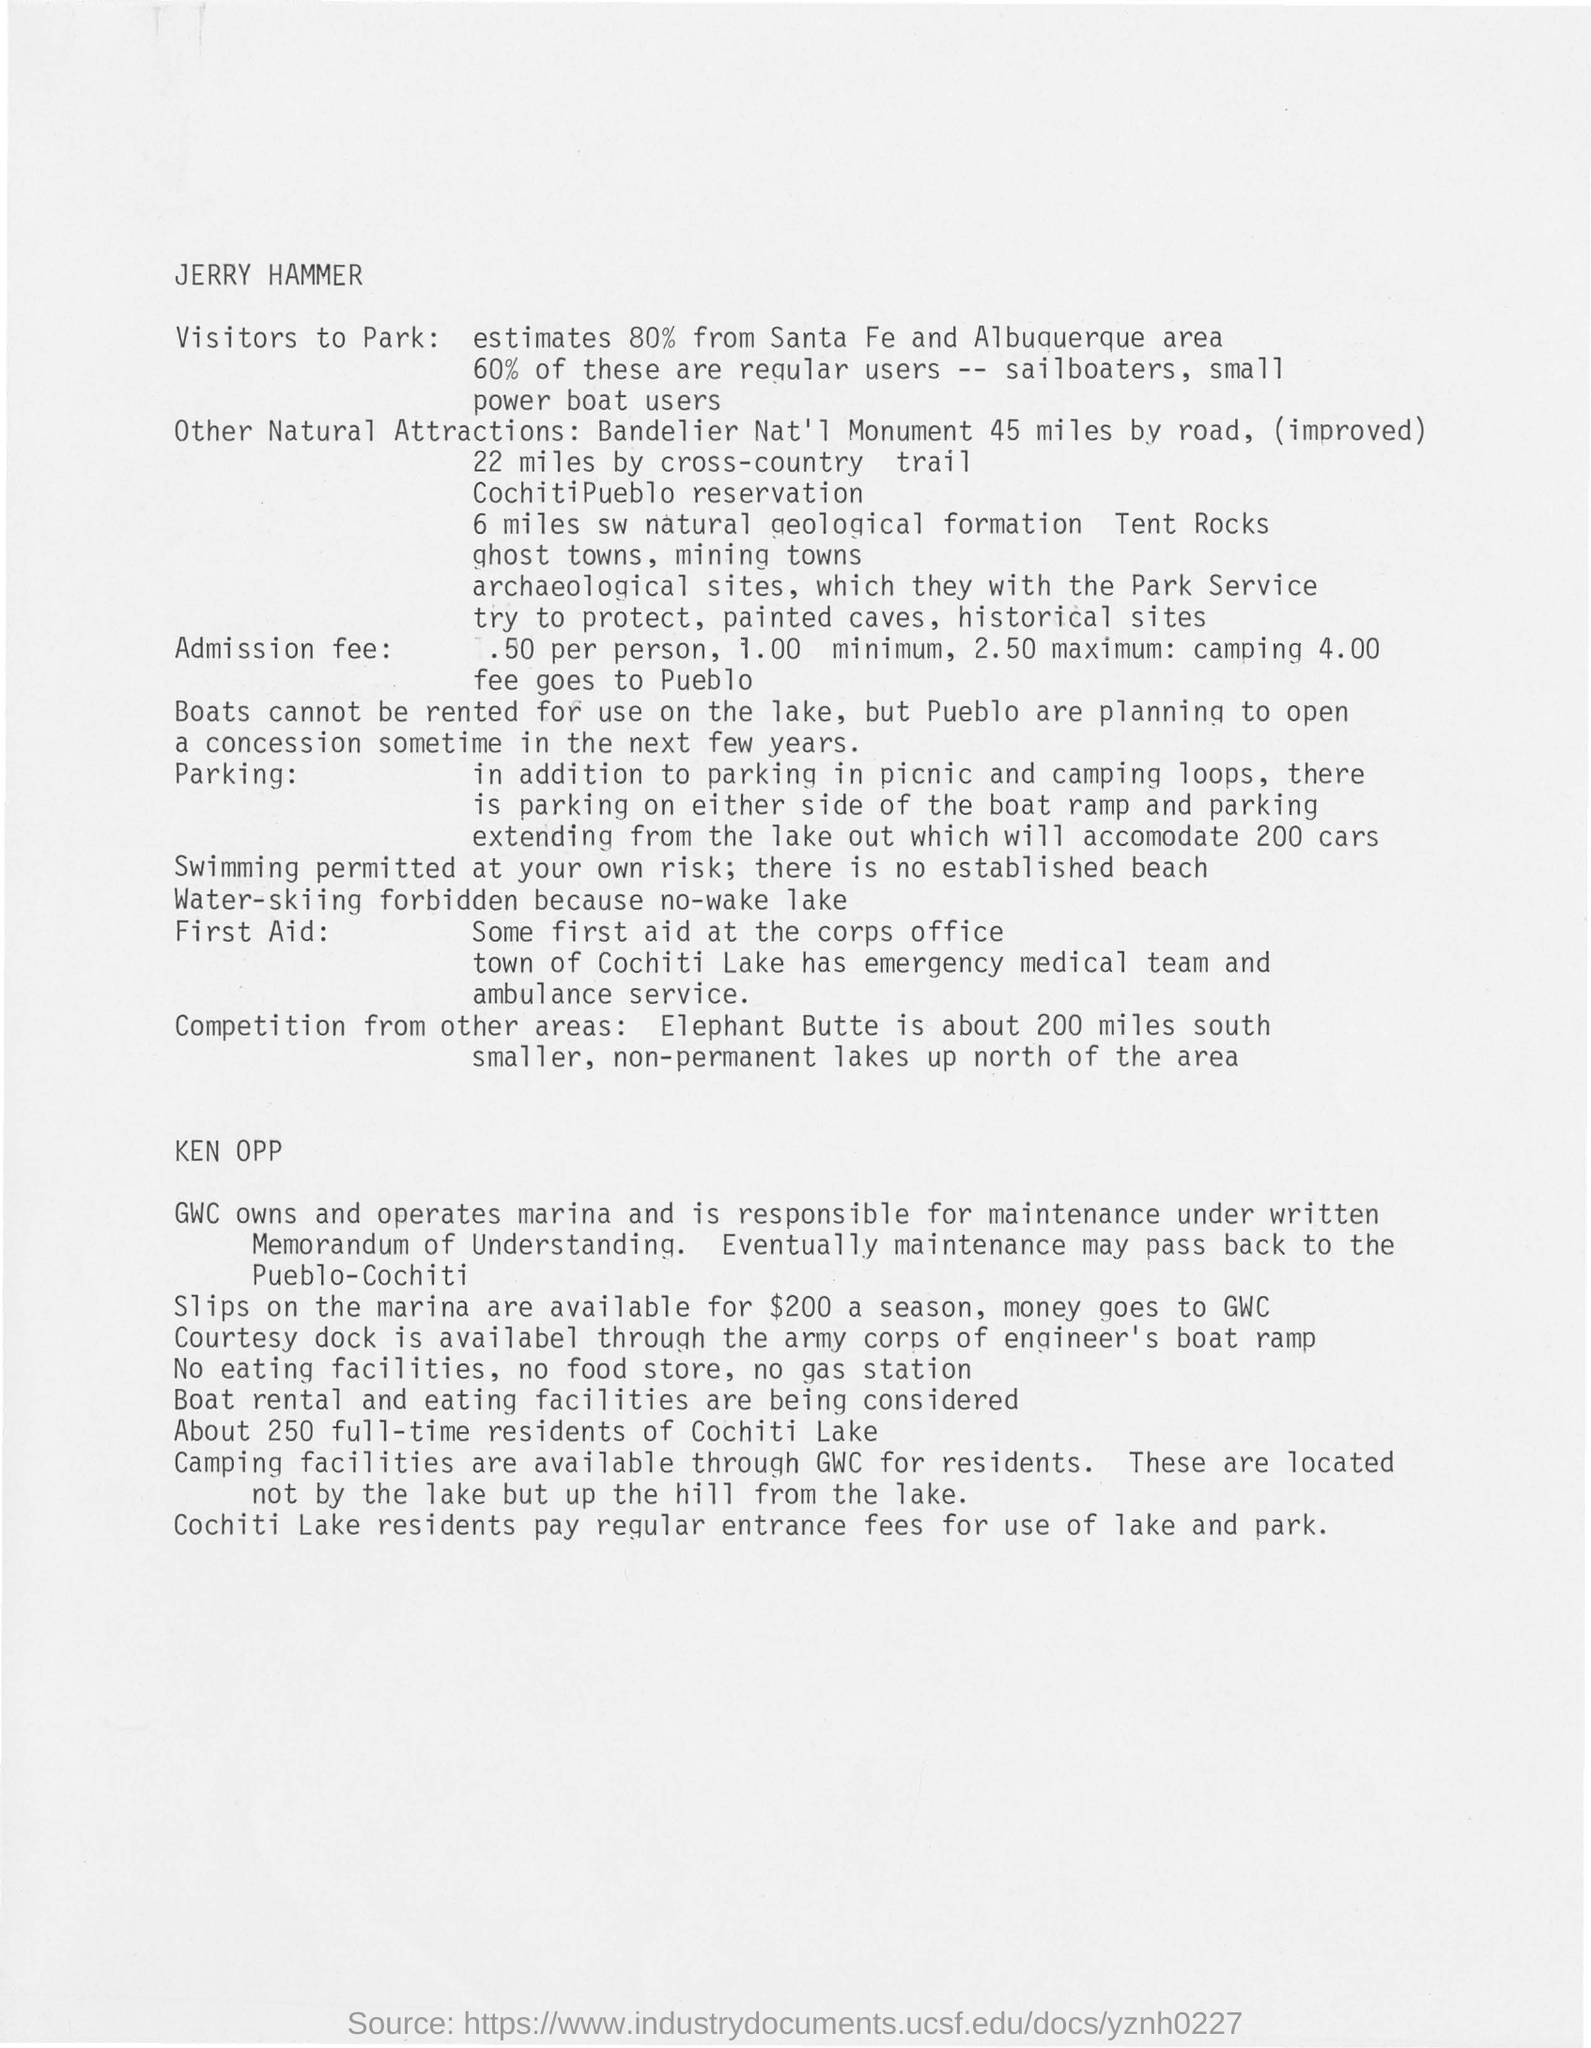Indicate a few pertinent items in this graphic. According to estimates, approximately 80% of visitors to Santa Fe and Albuquerque are from the local area. In the town of Cochiti Lake, there is an emergency medical team and ambulance service available to provide first aid to individuals in need. 